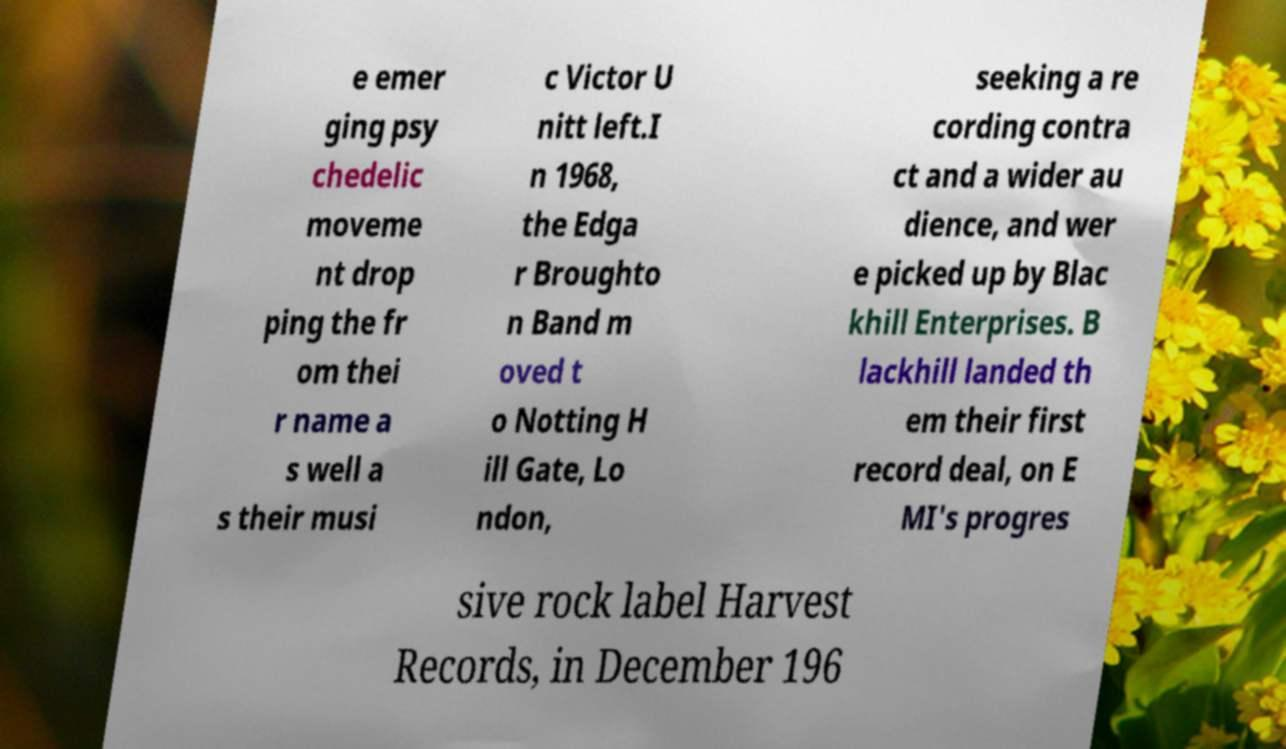There's text embedded in this image that I need extracted. Can you transcribe it verbatim? e emer ging psy chedelic moveme nt drop ping the fr om thei r name a s well a s their musi c Victor U nitt left.I n 1968, the Edga r Broughto n Band m oved t o Notting H ill Gate, Lo ndon, seeking a re cording contra ct and a wider au dience, and wer e picked up by Blac khill Enterprises. B lackhill landed th em their first record deal, on E MI's progres sive rock label Harvest Records, in December 196 